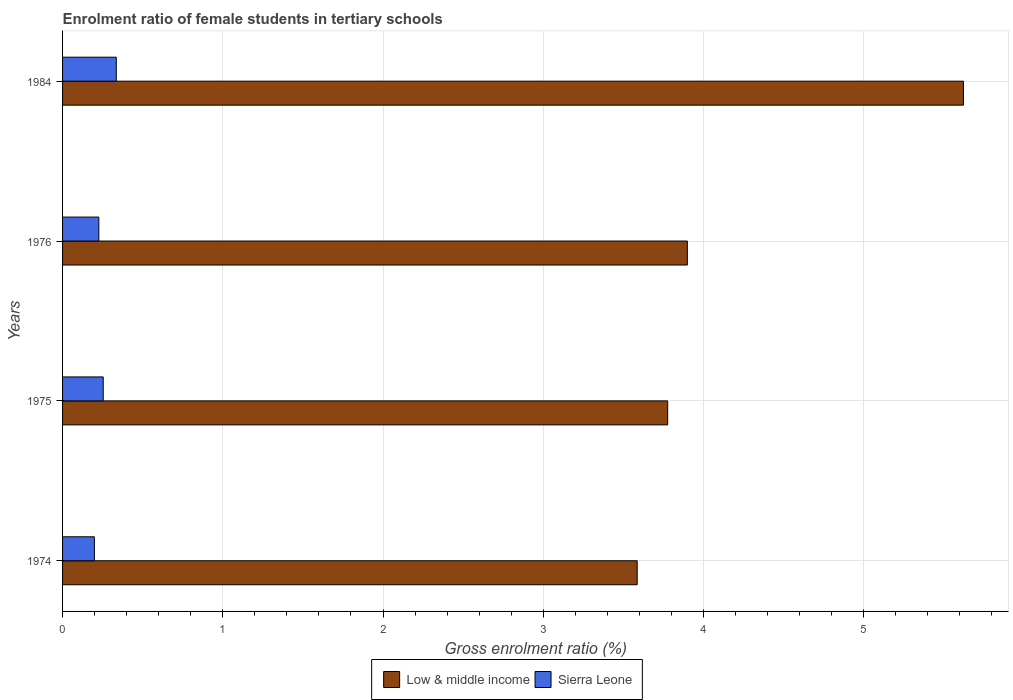How many groups of bars are there?
Give a very brief answer. 4. Are the number of bars per tick equal to the number of legend labels?
Your answer should be very brief. Yes. How many bars are there on the 1st tick from the bottom?
Make the answer very short. 2. In how many cases, is the number of bars for a given year not equal to the number of legend labels?
Offer a very short reply. 0. What is the enrolment ratio of female students in tertiary schools in Sierra Leone in 1974?
Give a very brief answer. 0.2. Across all years, what is the maximum enrolment ratio of female students in tertiary schools in Low & middle income?
Your answer should be very brief. 5.62. Across all years, what is the minimum enrolment ratio of female students in tertiary schools in Low & middle income?
Provide a succinct answer. 3.59. In which year was the enrolment ratio of female students in tertiary schools in Sierra Leone maximum?
Make the answer very short. 1984. In which year was the enrolment ratio of female students in tertiary schools in Low & middle income minimum?
Make the answer very short. 1974. What is the total enrolment ratio of female students in tertiary schools in Sierra Leone in the graph?
Provide a short and direct response. 1.01. What is the difference between the enrolment ratio of female students in tertiary schools in Low & middle income in 1974 and that in 1984?
Offer a terse response. -2.04. What is the difference between the enrolment ratio of female students in tertiary schools in Low & middle income in 1975 and the enrolment ratio of female students in tertiary schools in Sierra Leone in 1976?
Your response must be concise. 3.55. What is the average enrolment ratio of female students in tertiary schools in Sierra Leone per year?
Offer a terse response. 0.25. In the year 1974, what is the difference between the enrolment ratio of female students in tertiary schools in Sierra Leone and enrolment ratio of female students in tertiary schools in Low & middle income?
Your response must be concise. -3.39. In how many years, is the enrolment ratio of female students in tertiary schools in Low & middle income greater than 4.2 %?
Give a very brief answer. 1. What is the ratio of the enrolment ratio of female students in tertiary schools in Sierra Leone in 1975 to that in 1984?
Your answer should be compact. 0.76. What is the difference between the highest and the second highest enrolment ratio of female students in tertiary schools in Low & middle income?
Give a very brief answer. 1.72. What is the difference between the highest and the lowest enrolment ratio of female students in tertiary schools in Low & middle income?
Keep it short and to the point. 2.04. In how many years, is the enrolment ratio of female students in tertiary schools in Sierra Leone greater than the average enrolment ratio of female students in tertiary schools in Sierra Leone taken over all years?
Provide a succinct answer. 2. What does the 1st bar from the top in 1984 represents?
Ensure brevity in your answer.  Sierra Leone. What does the 1st bar from the bottom in 1976 represents?
Give a very brief answer. Low & middle income. How many bars are there?
Keep it short and to the point. 8. Are all the bars in the graph horizontal?
Your answer should be very brief. Yes. How many years are there in the graph?
Your answer should be very brief. 4. Are the values on the major ticks of X-axis written in scientific E-notation?
Make the answer very short. No. Does the graph contain any zero values?
Offer a terse response. No. Does the graph contain grids?
Provide a short and direct response. Yes. Where does the legend appear in the graph?
Keep it short and to the point. Bottom center. How many legend labels are there?
Your response must be concise. 2. What is the title of the graph?
Keep it short and to the point. Enrolment ratio of female students in tertiary schools. What is the label or title of the X-axis?
Make the answer very short. Gross enrolment ratio (%). What is the label or title of the Y-axis?
Make the answer very short. Years. What is the Gross enrolment ratio (%) of Low & middle income in 1974?
Your answer should be very brief. 3.59. What is the Gross enrolment ratio (%) in Sierra Leone in 1974?
Give a very brief answer. 0.2. What is the Gross enrolment ratio (%) in Low & middle income in 1975?
Make the answer very short. 3.78. What is the Gross enrolment ratio (%) in Sierra Leone in 1975?
Make the answer very short. 0.25. What is the Gross enrolment ratio (%) in Low & middle income in 1976?
Provide a succinct answer. 3.9. What is the Gross enrolment ratio (%) in Sierra Leone in 1976?
Keep it short and to the point. 0.23. What is the Gross enrolment ratio (%) in Low & middle income in 1984?
Your response must be concise. 5.62. What is the Gross enrolment ratio (%) of Sierra Leone in 1984?
Provide a succinct answer. 0.34. Across all years, what is the maximum Gross enrolment ratio (%) of Low & middle income?
Give a very brief answer. 5.62. Across all years, what is the maximum Gross enrolment ratio (%) in Sierra Leone?
Your answer should be compact. 0.34. Across all years, what is the minimum Gross enrolment ratio (%) in Low & middle income?
Provide a succinct answer. 3.59. Across all years, what is the minimum Gross enrolment ratio (%) in Sierra Leone?
Your response must be concise. 0.2. What is the total Gross enrolment ratio (%) in Low & middle income in the graph?
Your response must be concise. 16.88. What is the difference between the Gross enrolment ratio (%) of Low & middle income in 1974 and that in 1975?
Your response must be concise. -0.19. What is the difference between the Gross enrolment ratio (%) in Sierra Leone in 1974 and that in 1975?
Your answer should be very brief. -0.06. What is the difference between the Gross enrolment ratio (%) of Low & middle income in 1974 and that in 1976?
Provide a succinct answer. -0.31. What is the difference between the Gross enrolment ratio (%) in Sierra Leone in 1974 and that in 1976?
Provide a succinct answer. -0.03. What is the difference between the Gross enrolment ratio (%) in Low & middle income in 1974 and that in 1984?
Give a very brief answer. -2.04. What is the difference between the Gross enrolment ratio (%) of Sierra Leone in 1974 and that in 1984?
Make the answer very short. -0.14. What is the difference between the Gross enrolment ratio (%) in Low & middle income in 1975 and that in 1976?
Your answer should be compact. -0.12. What is the difference between the Gross enrolment ratio (%) in Sierra Leone in 1975 and that in 1976?
Offer a very short reply. 0.03. What is the difference between the Gross enrolment ratio (%) of Low & middle income in 1975 and that in 1984?
Your answer should be compact. -1.85. What is the difference between the Gross enrolment ratio (%) of Sierra Leone in 1975 and that in 1984?
Offer a very short reply. -0.08. What is the difference between the Gross enrolment ratio (%) of Low & middle income in 1976 and that in 1984?
Offer a very short reply. -1.72. What is the difference between the Gross enrolment ratio (%) in Sierra Leone in 1976 and that in 1984?
Your answer should be very brief. -0.11. What is the difference between the Gross enrolment ratio (%) in Low & middle income in 1974 and the Gross enrolment ratio (%) in Sierra Leone in 1975?
Keep it short and to the point. 3.33. What is the difference between the Gross enrolment ratio (%) of Low & middle income in 1974 and the Gross enrolment ratio (%) of Sierra Leone in 1976?
Your answer should be compact. 3.36. What is the difference between the Gross enrolment ratio (%) of Low & middle income in 1974 and the Gross enrolment ratio (%) of Sierra Leone in 1984?
Provide a succinct answer. 3.25. What is the difference between the Gross enrolment ratio (%) of Low & middle income in 1975 and the Gross enrolment ratio (%) of Sierra Leone in 1976?
Keep it short and to the point. 3.55. What is the difference between the Gross enrolment ratio (%) in Low & middle income in 1975 and the Gross enrolment ratio (%) in Sierra Leone in 1984?
Provide a succinct answer. 3.44. What is the difference between the Gross enrolment ratio (%) in Low & middle income in 1976 and the Gross enrolment ratio (%) in Sierra Leone in 1984?
Give a very brief answer. 3.56. What is the average Gross enrolment ratio (%) of Low & middle income per year?
Ensure brevity in your answer.  4.22. What is the average Gross enrolment ratio (%) in Sierra Leone per year?
Provide a short and direct response. 0.25. In the year 1974, what is the difference between the Gross enrolment ratio (%) of Low & middle income and Gross enrolment ratio (%) of Sierra Leone?
Your answer should be very brief. 3.39. In the year 1975, what is the difference between the Gross enrolment ratio (%) of Low & middle income and Gross enrolment ratio (%) of Sierra Leone?
Offer a terse response. 3.52. In the year 1976, what is the difference between the Gross enrolment ratio (%) in Low & middle income and Gross enrolment ratio (%) in Sierra Leone?
Give a very brief answer. 3.67. In the year 1984, what is the difference between the Gross enrolment ratio (%) of Low & middle income and Gross enrolment ratio (%) of Sierra Leone?
Ensure brevity in your answer.  5.29. What is the ratio of the Gross enrolment ratio (%) in Low & middle income in 1974 to that in 1975?
Make the answer very short. 0.95. What is the ratio of the Gross enrolment ratio (%) of Sierra Leone in 1974 to that in 1975?
Offer a very short reply. 0.78. What is the ratio of the Gross enrolment ratio (%) of Low & middle income in 1974 to that in 1976?
Make the answer very short. 0.92. What is the ratio of the Gross enrolment ratio (%) of Sierra Leone in 1974 to that in 1976?
Keep it short and to the point. 0.88. What is the ratio of the Gross enrolment ratio (%) in Low & middle income in 1974 to that in 1984?
Your answer should be very brief. 0.64. What is the ratio of the Gross enrolment ratio (%) of Sierra Leone in 1974 to that in 1984?
Make the answer very short. 0.59. What is the ratio of the Gross enrolment ratio (%) in Low & middle income in 1975 to that in 1976?
Ensure brevity in your answer.  0.97. What is the ratio of the Gross enrolment ratio (%) in Sierra Leone in 1975 to that in 1976?
Make the answer very short. 1.12. What is the ratio of the Gross enrolment ratio (%) of Low & middle income in 1975 to that in 1984?
Give a very brief answer. 0.67. What is the ratio of the Gross enrolment ratio (%) in Sierra Leone in 1975 to that in 1984?
Keep it short and to the point. 0.76. What is the ratio of the Gross enrolment ratio (%) of Low & middle income in 1976 to that in 1984?
Your answer should be compact. 0.69. What is the ratio of the Gross enrolment ratio (%) of Sierra Leone in 1976 to that in 1984?
Give a very brief answer. 0.68. What is the difference between the highest and the second highest Gross enrolment ratio (%) in Low & middle income?
Offer a very short reply. 1.72. What is the difference between the highest and the second highest Gross enrolment ratio (%) of Sierra Leone?
Keep it short and to the point. 0.08. What is the difference between the highest and the lowest Gross enrolment ratio (%) in Low & middle income?
Provide a succinct answer. 2.04. What is the difference between the highest and the lowest Gross enrolment ratio (%) in Sierra Leone?
Offer a terse response. 0.14. 